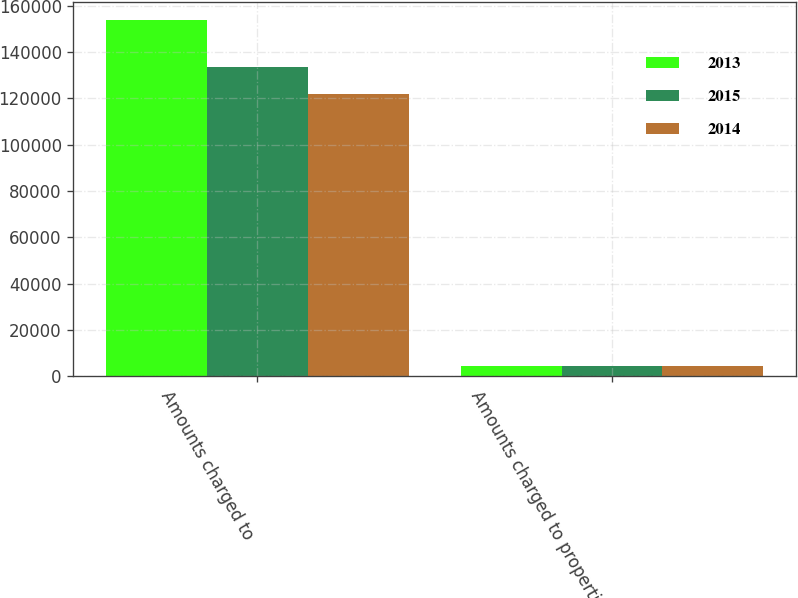Convert chart. <chart><loc_0><loc_0><loc_500><loc_500><stacked_bar_chart><ecel><fcel>Amounts charged to<fcel>Amounts charged to properties<nl><fcel>2013<fcel>154098<fcel>4324<nl><fcel>2015<fcel>133730<fcel>4393<nl><fcel>2014<fcel>121996<fcel>4510<nl></chart> 